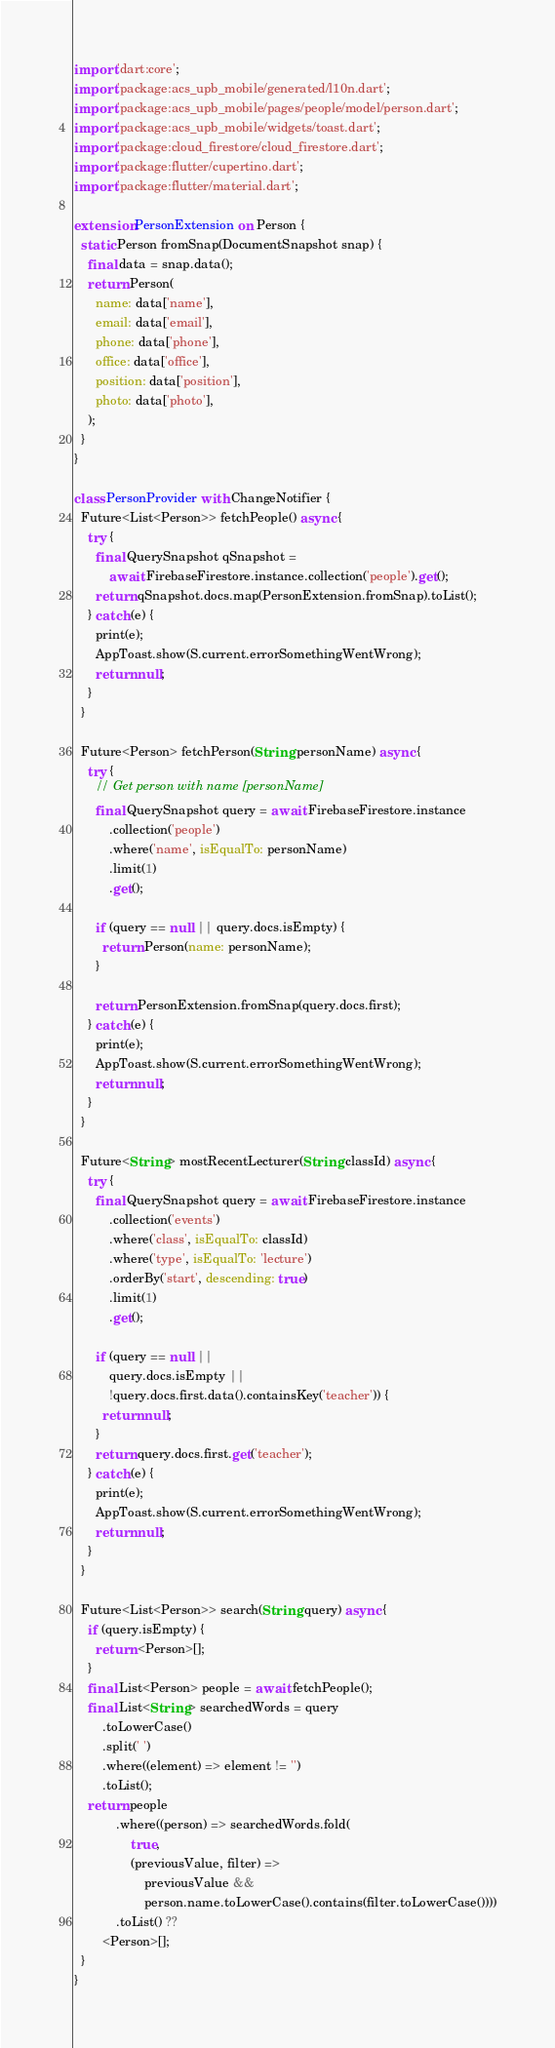Convert code to text. <code><loc_0><loc_0><loc_500><loc_500><_Dart_>import 'dart:core';
import 'package:acs_upb_mobile/generated/l10n.dart';
import 'package:acs_upb_mobile/pages/people/model/person.dart';
import 'package:acs_upb_mobile/widgets/toast.dart';
import 'package:cloud_firestore/cloud_firestore.dart';
import 'package:flutter/cupertino.dart';
import 'package:flutter/material.dart';

extension PersonExtension on Person {
  static Person fromSnap(DocumentSnapshot snap) {
    final data = snap.data();
    return Person(
      name: data['name'],
      email: data['email'],
      phone: data['phone'],
      office: data['office'],
      position: data['position'],
      photo: data['photo'],
    );
  }
}

class PersonProvider with ChangeNotifier {
  Future<List<Person>> fetchPeople() async {
    try {
      final QuerySnapshot qSnapshot =
          await FirebaseFirestore.instance.collection('people').get();
      return qSnapshot.docs.map(PersonExtension.fromSnap).toList();
    } catch (e) {
      print(e);
      AppToast.show(S.current.errorSomethingWentWrong);
      return null;
    }
  }

  Future<Person> fetchPerson(String personName) async {
    try {
      // Get person with name [personName]
      final QuerySnapshot query = await FirebaseFirestore.instance
          .collection('people')
          .where('name', isEqualTo: personName)
          .limit(1)
          .get();

      if (query == null || query.docs.isEmpty) {
        return Person(name: personName);
      }

      return PersonExtension.fromSnap(query.docs.first);
    } catch (e) {
      print(e);
      AppToast.show(S.current.errorSomethingWentWrong);
      return null;
    }
  }

  Future<String> mostRecentLecturer(String classId) async {
    try {
      final QuerySnapshot query = await FirebaseFirestore.instance
          .collection('events')
          .where('class', isEqualTo: classId)
          .where('type', isEqualTo: 'lecture')
          .orderBy('start', descending: true)
          .limit(1)
          .get();

      if (query == null ||
          query.docs.isEmpty ||
          !query.docs.first.data().containsKey('teacher')) {
        return null;
      }
      return query.docs.first.get('teacher');
    } catch (e) {
      print(e);
      AppToast.show(S.current.errorSomethingWentWrong);
      return null;
    }
  }

  Future<List<Person>> search(String query) async {
    if (query.isEmpty) {
      return <Person>[];
    }
    final List<Person> people = await fetchPeople();
    final List<String> searchedWords = query
        .toLowerCase()
        .split(' ')
        .where((element) => element != '')
        .toList();
    return people
            .where((person) => searchedWords.fold(
                true,
                (previousValue, filter) =>
                    previousValue &&
                    person.name.toLowerCase().contains(filter.toLowerCase())))
            .toList() ??
        <Person>[];
  }
}
</code> 